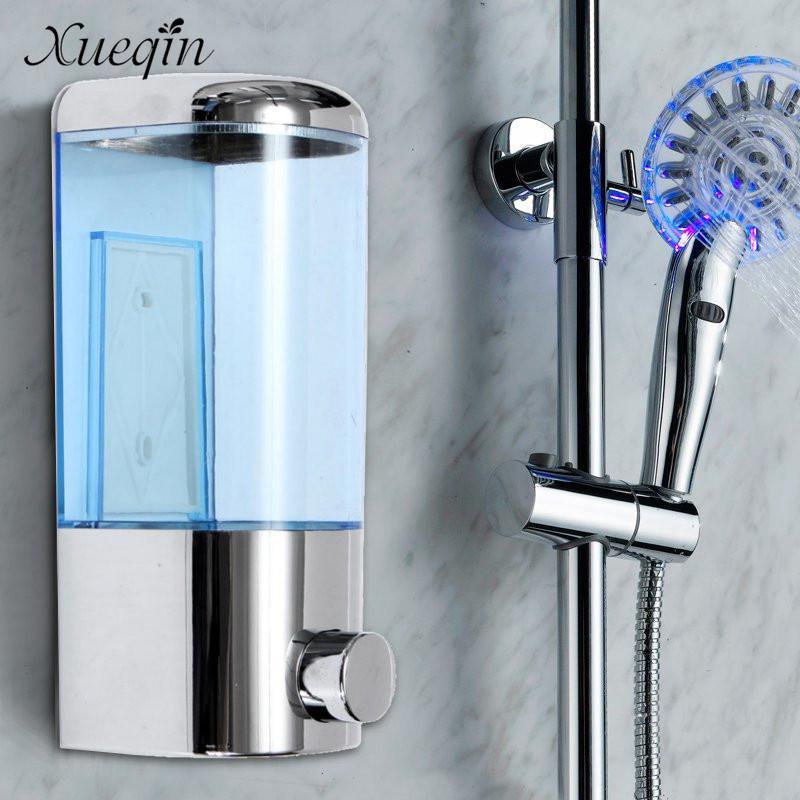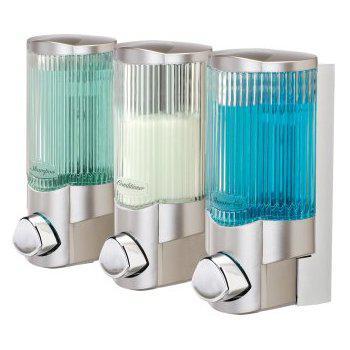The first image is the image on the left, the second image is the image on the right. Examine the images to the left and right. Is the description "There are three dispensers in the image on the right." accurate? Answer yes or no. Yes. The first image is the image on the left, the second image is the image on the right. Analyze the images presented: Is the assertion "Five bathroom dispensers are divided into groups of two and three, each grouping having at least one liquid color in common with the other." valid? Answer yes or no. No. 